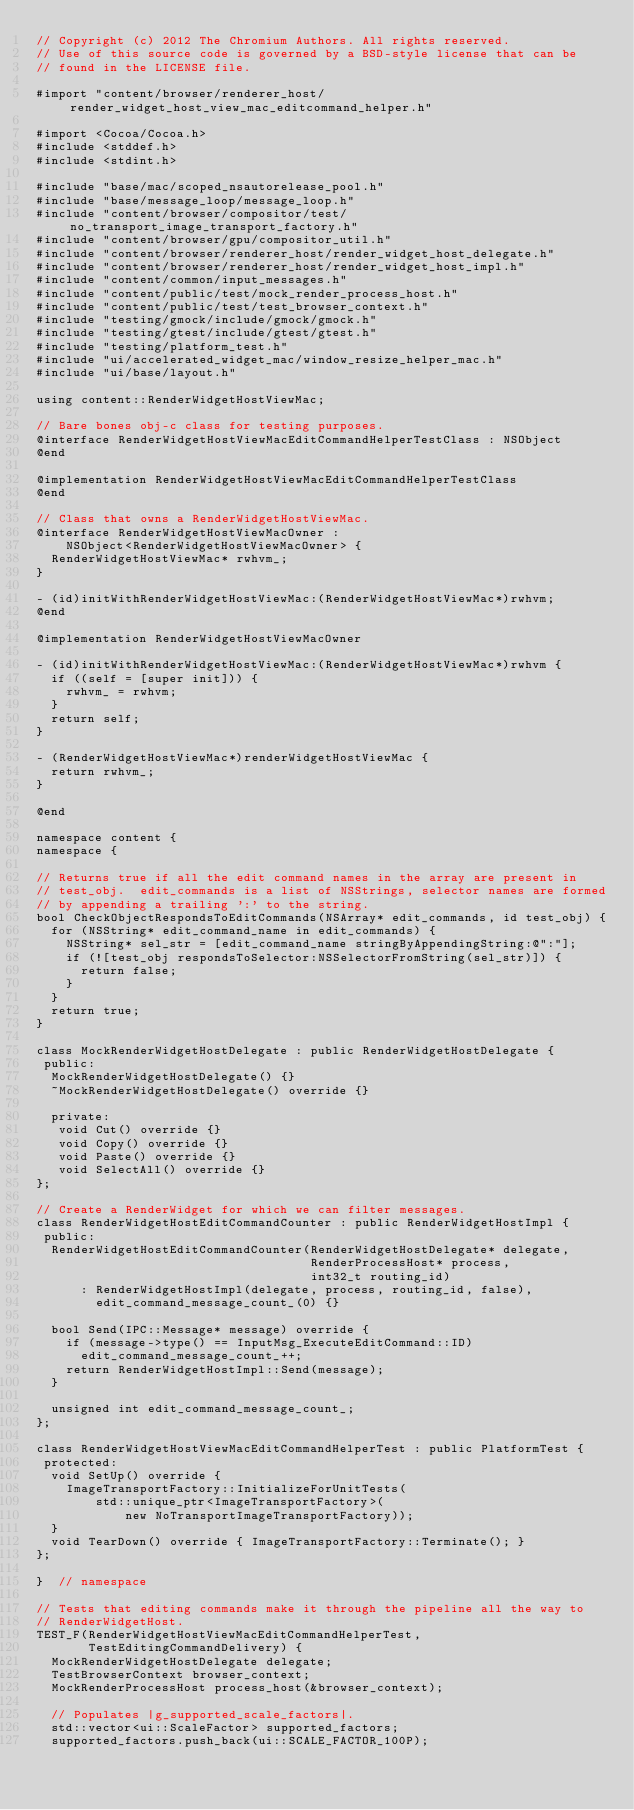Convert code to text. <code><loc_0><loc_0><loc_500><loc_500><_ObjectiveC_>// Copyright (c) 2012 The Chromium Authors. All rights reserved.
// Use of this source code is governed by a BSD-style license that can be
// found in the LICENSE file.

#import "content/browser/renderer_host/render_widget_host_view_mac_editcommand_helper.h"

#import <Cocoa/Cocoa.h>
#include <stddef.h>
#include <stdint.h>

#include "base/mac/scoped_nsautorelease_pool.h"
#include "base/message_loop/message_loop.h"
#include "content/browser/compositor/test/no_transport_image_transport_factory.h"
#include "content/browser/gpu/compositor_util.h"
#include "content/browser/renderer_host/render_widget_host_delegate.h"
#include "content/browser/renderer_host/render_widget_host_impl.h"
#include "content/common/input_messages.h"
#include "content/public/test/mock_render_process_host.h"
#include "content/public/test/test_browser_context.h"
#include "testing/gmock/include/gmock/gmock.h"
#include "testing/gtest/include/gtest/gtest.h"
#include "testing/platform_test.h"
#include "ui/accelerated_widget_mac/window_resize_helper_mac.h"
#include "ui/base/layout.h"

using content::RenderWidgetHostViewMac;

// Bare bones obj-c class for testing purposes.
@interface RenderWidgetHostViewMacEditCommandHelperTestClass : NSObject
@end

@implementation RenderWidgetHostViewMacEditCommandHelperTestClass
@end

// Class that owns a RenderWidgetHostViewMac.
@interface RenderWidgetHostViewMacOwner :
    NSObject<RenderWidgetHostViewMacOwner> {
  RenderWidgetHostViewMac* rwhvm_;
}

- (id)initWithRenderWidgetHostViewMac:(RenderWidgetHostViewMac*)rwhvm;
@end

@implementation RenderWidgetHostViewMacOwner

- (id)initWithRenderWidgetHostViewMac:(RenderWidgetHostViewMac*)rwhvm {
  if ((self = [super init])) {
    rwhvm_ = rwhvm;
  }
  return self;
}

- (RenderWidgetHostViewMac*)renderWidgetHostViewMac {
  return rwhvm_;
}

@end

namespace content {
namespace {

// Returns true if all the edit command names in the array are present in
// test_obj.  edit_commands is a list of NSStrings, selector names are formed
// by appending a trailing ':' to the string.
bool CheckObjectRespondsToEditCommands(NSArray* edit_commands, id test_obj) {
  for (NSString* edit_command_name in edit_commands) {
    NSString* sel_str = [edit_command_name stringByAppendingString:@":"];
    if (![test_obj respondsToSelector:NSSelectorFromString(sel_str)]) {
      return false;
    }
  }
  return true;
}

class MockRenderWidgetHostDelegate : public RenderWidgetHostDelegate {
 public:
  MockRenderWidgetHostDelegate() {}
  ~MockRenderWidgetHostDelegate() override {}

  private:
   void Cut() override {}
   void Copy() override {}
   void Paste() override {}
   void SelectAll() override {}
};

// Create a RenderWidget for which we can filter messages.
class RenderWidgetHostEditCommandCounter : public RenderWidgetHostImpl {
 public:
  RenderWidgetHostEditCommandCounter(RenderWidgetHostDelegate* delegate,
                                     RenderProcessHost* process,
                                     int32_t routing_id)
      : RenderWidgetHostImpl(delegate, process, routing_id, false),
        edit_command_message_count_(0) {}

  bool Send(IPC::Message* message) override {
    if (message->type() == InputMsg_ExecuteEditCommand::ID)
      edit_command_message_count_++;
    return RenderWidgetHostImpl::Send(message);
  }

  unsigned int edit_command_message_count_;
};

class RenderWidgetHostViewMacEditCommandHelperTest : public PlatformTest {
 protected:
  void SetUp() override {
    ImageTransportFactory::InitializeForUnitTests(
        std::unique_ptr<ImageTransportFactory>(
            new NoTransportImageTransportFactory));
  }
  void TearDown() override { ImageTransportFactory::Terminate(); }
};

}  // namespace

// Tests that editing commands make it through the pipeline all the way to
// RenderWidgetHost.
TEST_F(RenderWidgetHostViewMacEditCommandHelperTest,
       TestEditingCommandDelivery) {
  MockRenderWidgetHostDelegate delegate;
  TestBrowserContext browser_context;
  MockRenderProcessHost process_host(&browser_context);

  // Populates |g_supported_scale_factors|.
  std::vector<ui::ScaleFactor> supported_factors;
  supported_factors.push_back(ui::SCALE_FACTOR_100P);</code> 